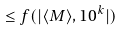<formula> <loc_0><loc_0><loc_500><loc_500>\leq f ( | \langle M \rangle , 1 0 ^ { k } | )</formula> 